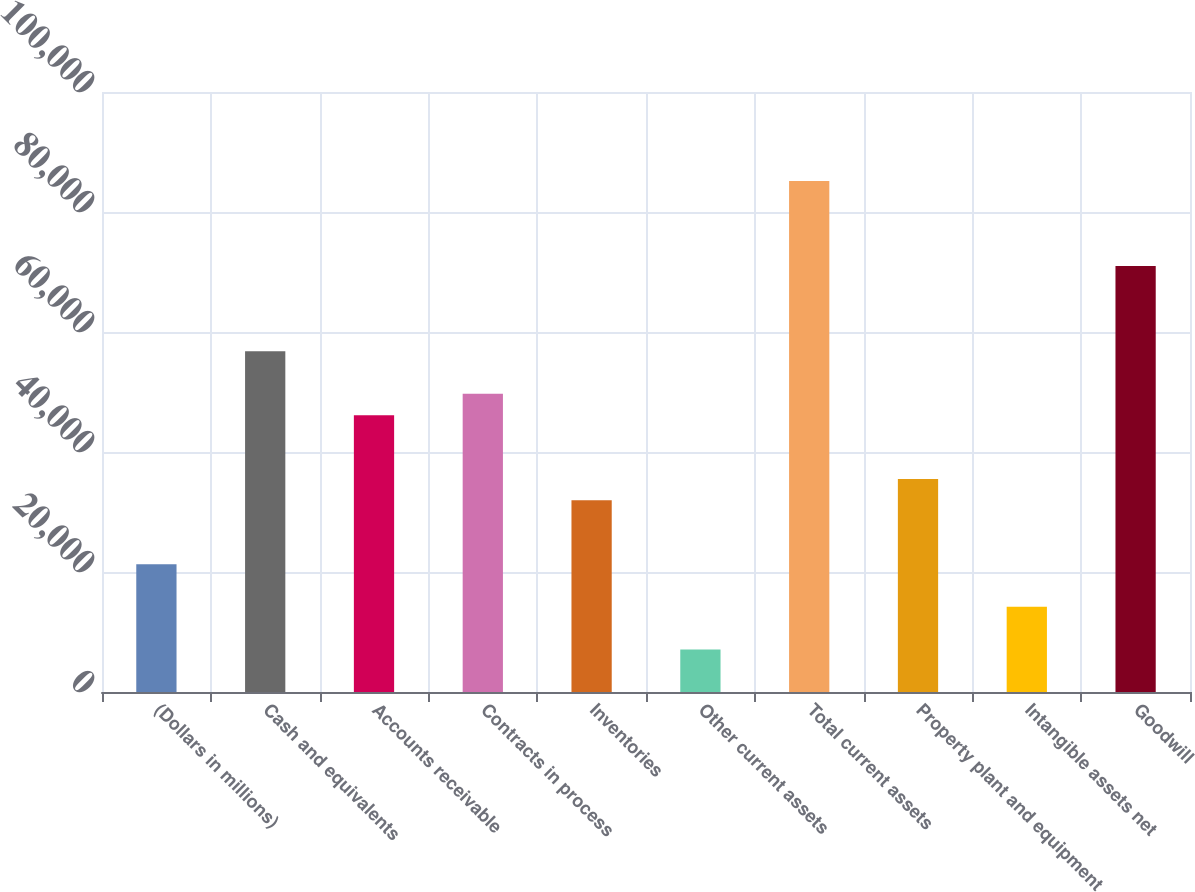Convert chart to OTSL. <chart><loc_0><loc_0><loc_500><loc_500><bar_chart><fcel>(Dollars in millions)<fcel>Cash and equivalents<fcel>Accounts receivable<fcel>Contracts in process<fcel>Inventories<fcel>Other current assets<fcel>Total current assets<fcel>Property plant and equipment<fcel>Intangible assets net<fcel>Goodwill<nl><fcel>21296.8<fcel>56789.8<fcel>46141.9<fcel>49691.2<fcel>31944.7<fcel>7099.6<fcel>85184.2<fcel>35494<fcel>14198.2<fcel>70987<nl></chart> 